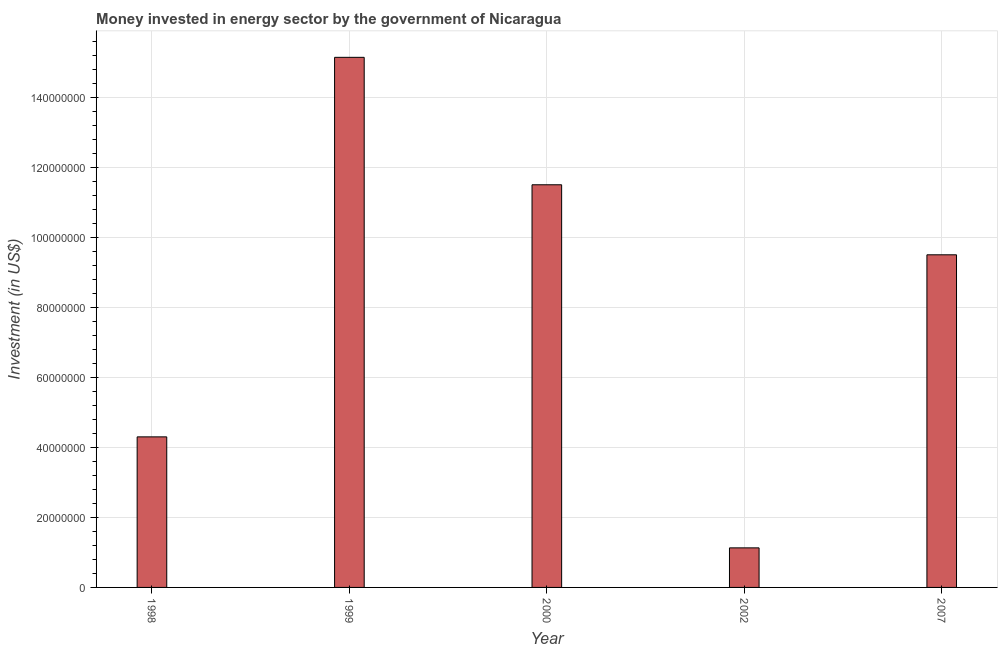Does the graph contain any zero values?
Provide a short and direct response. No. Does the graph contain grids?
Give a very brief answer. Yes. What is the title of the graph?
Provide a succinct answer. Money invested in energy sector by the government of Nicaragua. What is the label or title of the Y-axis?
Make the answer very short. Investment (in US$). What is the investment in energy in 1999?
Your response must be concise. 1.51e+08. Across all years, what is the maximum investment in energy?
Your answer should be very brief. 1.51e+08. Across all years, what is the minimum investment in energy?
Give a very brief answer. 1.13e+07. In which year was the investment in energy maximum?
Keep it short and to the point. 1999. What is the sum of the investment in energy?
Give a very brief answer. 4.16e+08. What is the difference between the investment in energy in 1998 and 2002?
Provide a short and direct response. 3.17e+07. What is the average investment in energy per year?
Ensure brevity in your answer.  8.31e+07. What is the median investment in energy?
Make the answer very short. 9.50e+07. What is the ratio of the investment in energy in 1999 to that in 2007?
Ensure brevity in your answer.  1.59. Is the investment in energy in 1998 less than that in 1999?
Your response must be concise. Yes. What is the difference between the highest and the second highest investment in energy?
Give a very brief answer. 3.64e+07. What is the difference between the highest and the lowest investment in energy?
Ensure brevity in your answer.  1.40e+08. In how many years, is the investment in energy greater than the average investment in energy taken over all years?
Offer a terse response. 3. How many bars are there?
Ensure brevity in your answer.  5. Are all the bars in the graph horizontal?
Your response must be concise. No. What is the difference between two consecutive major ticks on the Y-axis?
Make the answer very short. 2.00e+07. Are the values on the major ticks of Y-axis written in scientific E-notation?
Give a very brief answer. No. What is the Investment (in US$) in 1998?
Make the answer very short. 4.30e+07. What is the Investment (in US$) in 1999?
Give a very brief answer. 1.51e+08. What is the Investment (in US$) in 2000?
Keep it short and to the point. 1.15e+08. What is the Investment (in US$) in 2002?
Make the answer very short. 1.13e+07. What is the Investment (in US$) of 2007?
Your answer should be compact. 9.50e+07. What is the difference between the Investment (in US$) in 1998 and 1999?
Give a very brief answer. -1.08e+08. What is the difference between the Investment (in US$) in 1998 and 2000?
Provide a succinct answer. -7.20e+07. What is the difference between the Investment (in US$) in 1998 and 2002?
Give a very brief answer. 3.17e+07. What is the difference between the Investment (in US$) in 1998 and 2007?
Offer a very short reply. -5.20e+07. What is the difference between the Investment (in US$) in 1999 and 2000?
Make the answer very short. 3.64e+07. What is the difference between the Investment (in US$) in 1999 and 2002?
Ensure brevity in your answer.  1.40e+08. What is the difference between the Investment (in US$) in 1999 and 2007?
Ensure brevity in your answer.  5.64e+07. What is the difference between the Investment (in US$) in 2000 and 2002?
Make the answer very short. 1.04e+08. What is the difference between the Investment (in US$) in 2000 and 2007?
Ensure brevity in your answer.  2.00e+07. What is the difference between the Investment (in US$) in 2002 and 2007?
Ensure brevity in your answer.  -8.37e+07. What is the ratio of the Investment (in US$) in 1998 to that in 1999?
Your answer should be compact. 0.28. What is the ratio of the Investment (in US$) in 1998 to that in 2000?
Offer a terse response. 0.37. What is the ratio of the Investment (in US$) in 1998 to that in 2002?
Offer a very short reply. 3.81. What is the ratio of the Investment (in US$) in 1998 to that in 2007?
Give a very brief answer. 0.45. What is the ratio of the Investment (in US$) in 1999 to that in 2000?
Give a very brief answer. 1.32. What is the ratio of the Investment (in US$) in 1999 to that in 2002?
Your answer should be very brief. 13.4. What is the ratio of the Investment (in US$) in 1999 to that in 2007?
Your answer should be compact. 1.59. What is the ratio of the Investment (in US$) in 2000 to that in 2002?
Provide a short and direct response. 10.18. What is the ratio of the Investment (in US$) in 2000 to that in 2007?
Provide a succinct answer. 1.21. What is the ratio of the Investment (in US$) in 2002 to that in 2007?
Ensure brevity in your answer.  0.12. 